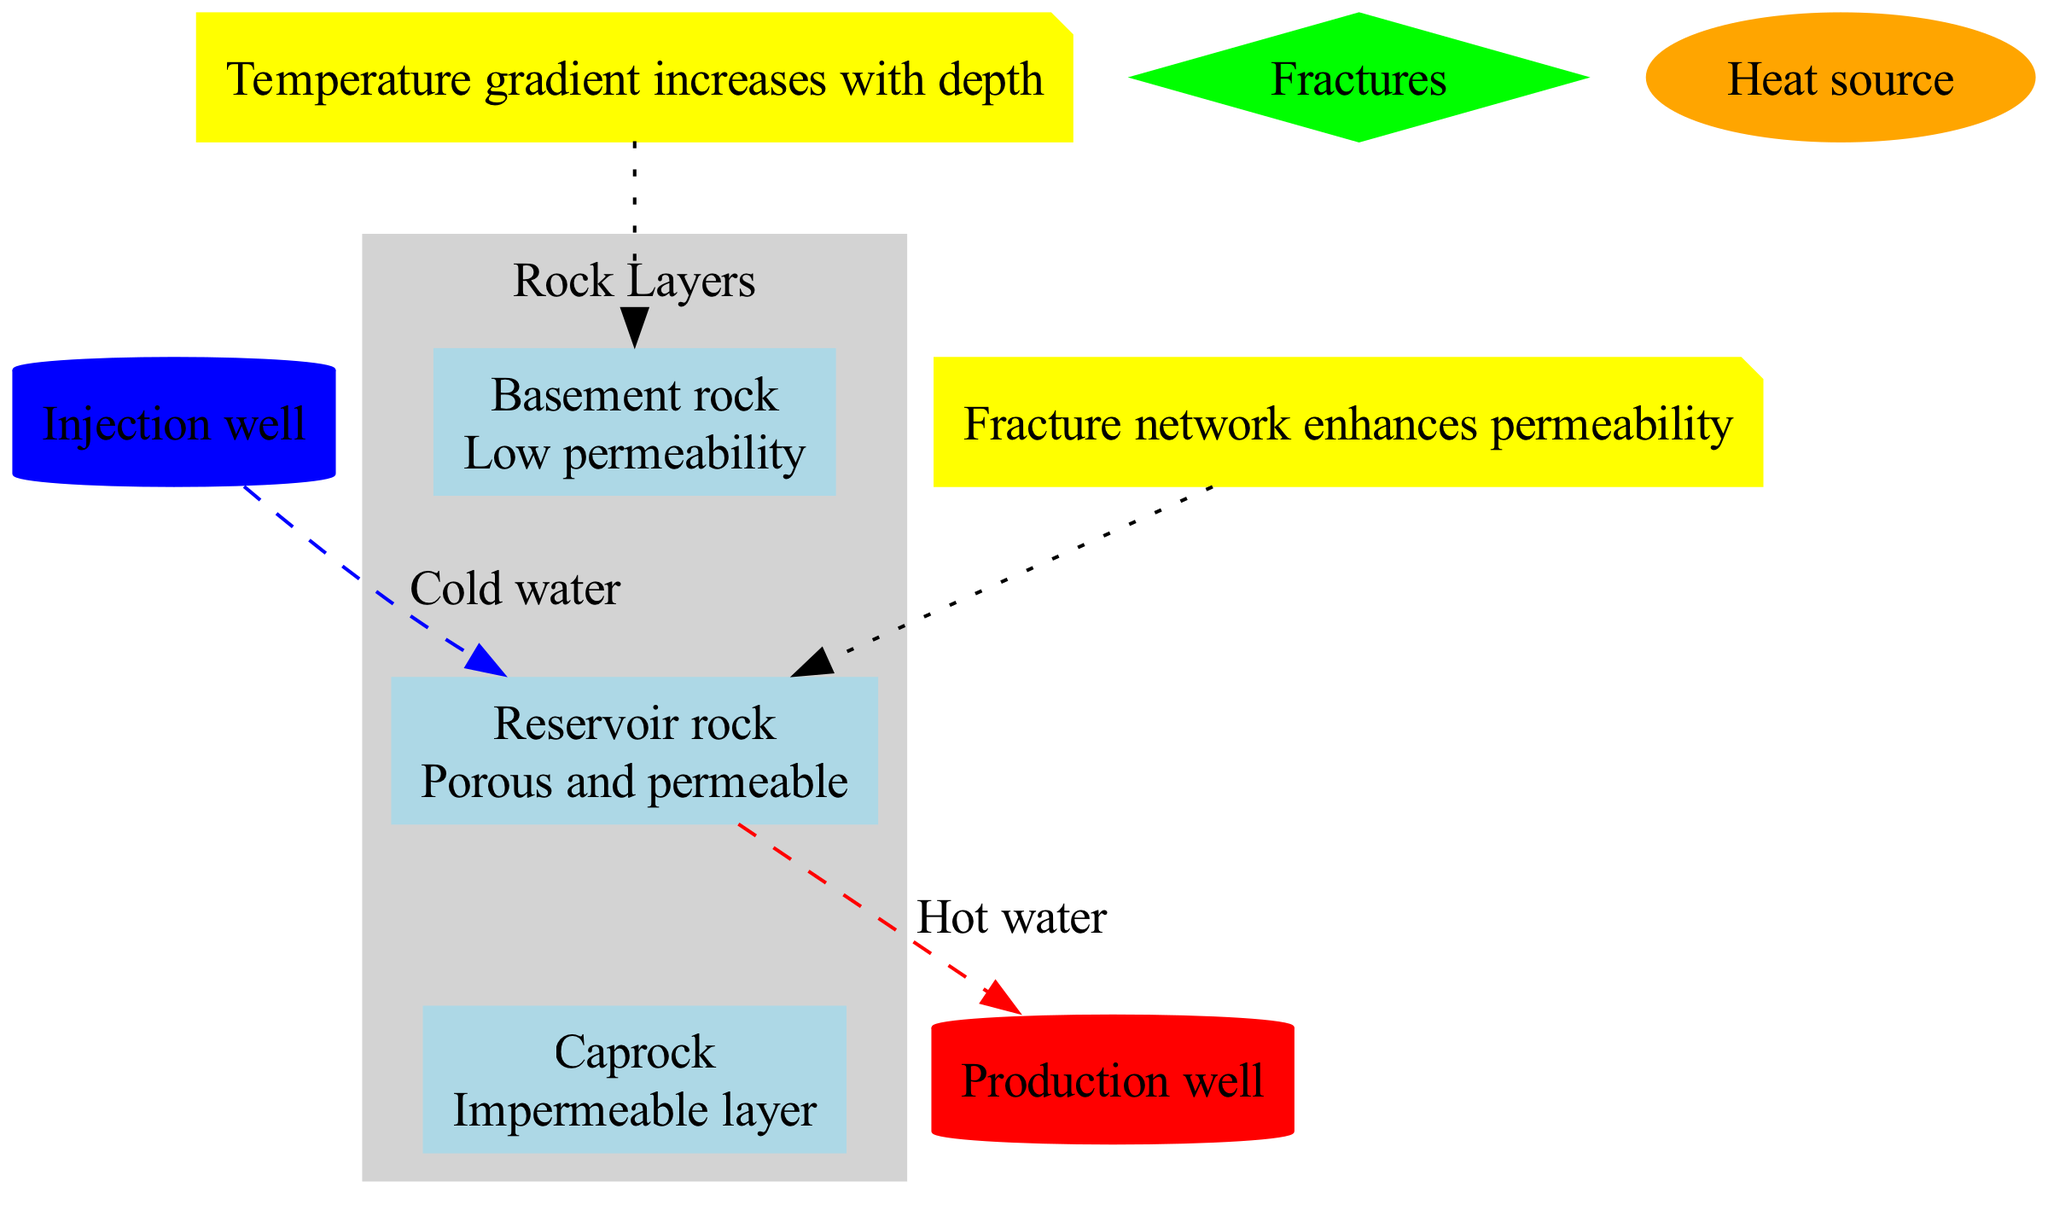What are the layers of the geothermal reservoir? The layers listed in the diagram include Caprock, Reservoir rock, and Basement rock. This information is gathered from the "Rock Layers" section of the diagram that categorizes these layers.
Answer: Caprock, Reservoir rock, Basement rock What type of fluid flow is represented as downward flow? The diagram indicates that cold water flows downward, as shown at the edge connecting the injection well to the reservoir rock, where 'Cold water' is labeled with a downward direction.
Answer: Cold water How many features are labeled in the diagram? There are four features indicated: Fractures, Injection well, Production well, and Heat source. By counting these elements listed under features, the total is established.
Answer: Four Which layer is described as impermeable? The Caprock is described as the impermeable layer, which is mentioned in the description section for that particular layer.
Answer: Caprock What is the purpose of the Production well in the diagram? The Production well is indicated as for hot water extraction, as labeled in the diagram, revealing its function in the context of fluid movement in geothermal systems.
Answer: Hot water extraction What is the role of fractures in the geothermal reservoir? The annotation states that the fracture network enhances permeability, indicating its critical role in allowing fluid movement within the reservoir rock layer.
Answer: Enhances permeability Which feature is associated with cold water input? The Injection well is associated with cold water input, according to the feature descriptions, indicating its purpose of injecting cold water into the system.
Answer: Injection well Which layer has the highest permeability? The Reservoir rock is characterized as porous and permeable, which makes it the layer with the highest permeability compared to Caprock and Basement rock.
Answer: Reservoir rock What does the vertical axis indicate regarding temperature in the diagram? The annotation states that the temperature gradient increases with depth, highlighting that as you move further down, temperatures rise within the geothermal system.
Answer: Temperature gradient increases with depth 